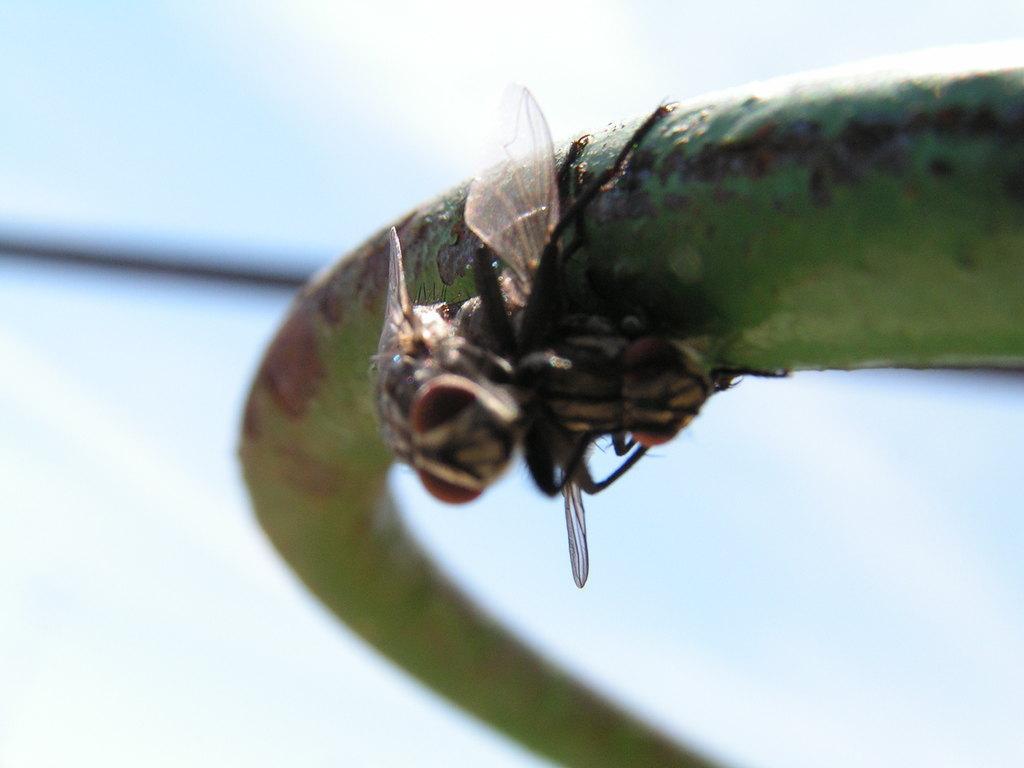Describe this image in one or two sentences. In this image I can see green colour thing and on it I can see few insects. I can see this image is little bit blurry from background. 